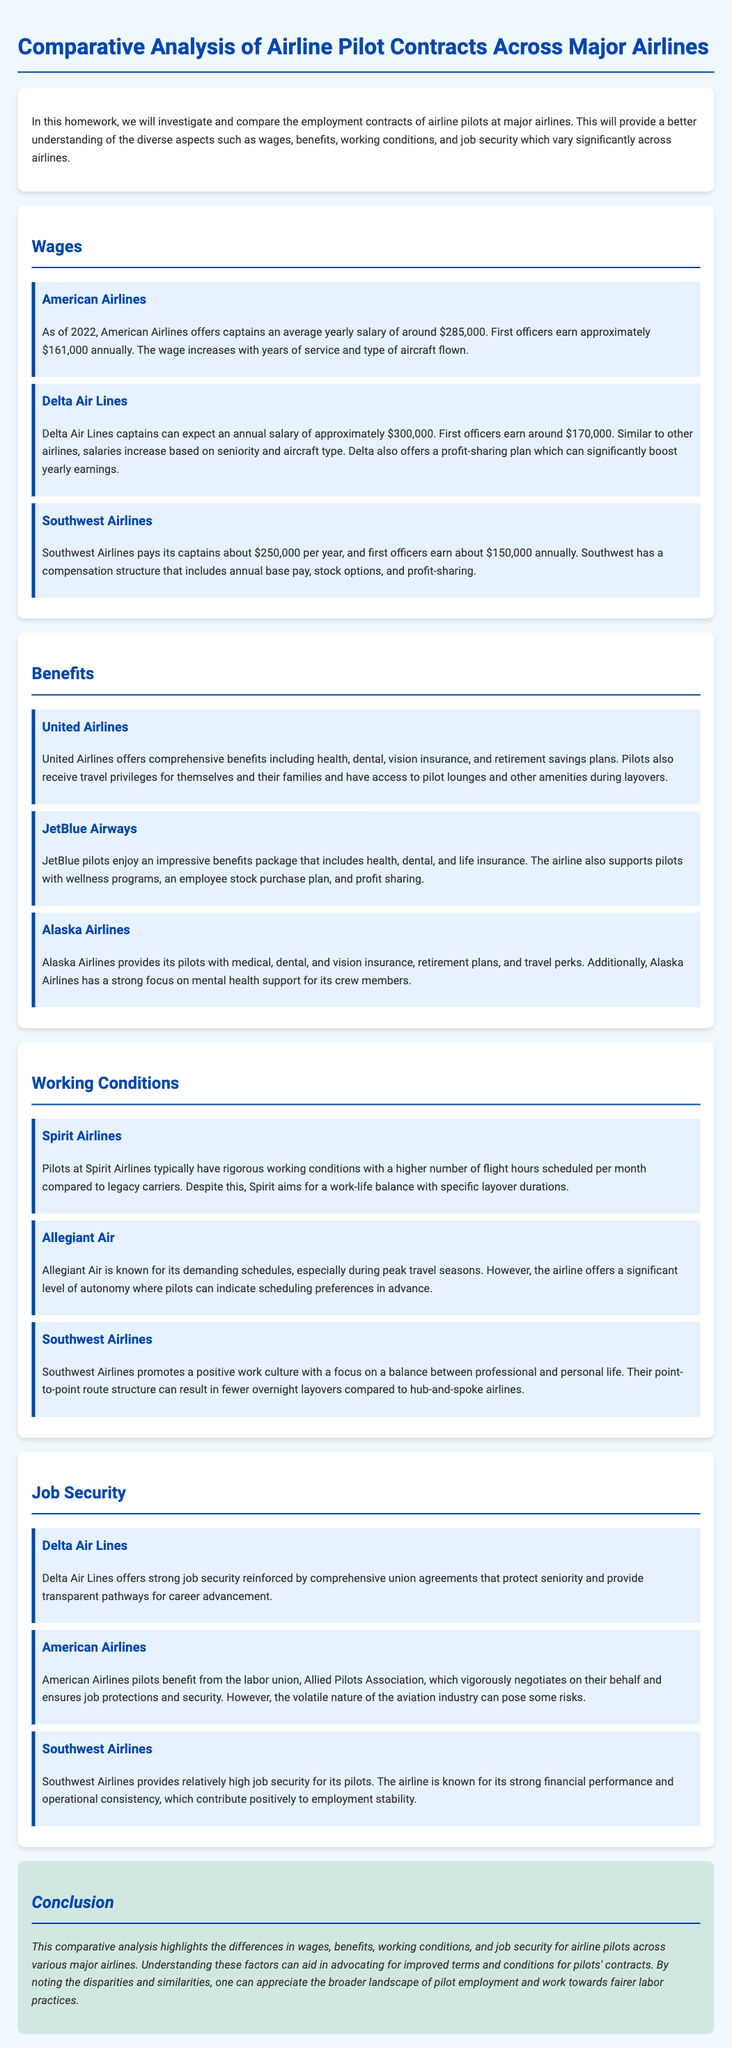What is the average yearly salary of captains at Delta Air Lines? The average yearly salary for captains at Delta Air Lines is approximately $300,000.
Answer: $300,000 What type of insurance does Alaska Airlines provide its pilots? Alaska Airlines provides medical, dental, and vision insurance to its pilots.
Answer: Medical, dental, and vision insurance Which airline has a focus on mental health support for its crew members? Alaska Airlines emphasizes mental health support within its benefits for pilots.
Answer: Alaska Airlines What is a unique feature of Delta Air Lines' compensation structure compared to others? Delta Air Lines offers a profit-sharing plan that can significantly boost yearly earnings for pilots.
Answer: Profit-sharing plan How many flight hours do pilots at Spirit Airlines typically have scheduled per month? Spirit Airlines pilots typically have a higher number of flight hours scheduled per month compared to legacy carriers.
Answer: Higher number of flight hours What is one aspect that contributes to job security at Southwest Airlines? Southwest Airlines has a strong financial performance that contributes positively to employment stability.
Answer: Strong financial performance Which airline has comprehensive benefits that include travel privileges? United Airlines offers comprehensive benefits including travel privileges for pilots and their families.
Answer: United Airlines What does the Allied Pilots Association do for American Airlines pilots? The Allied Pilots Association negotiates on behalf of American Airlines pilots to ensure job protections and security.
Answer: Negotiates on behalf of pilots 